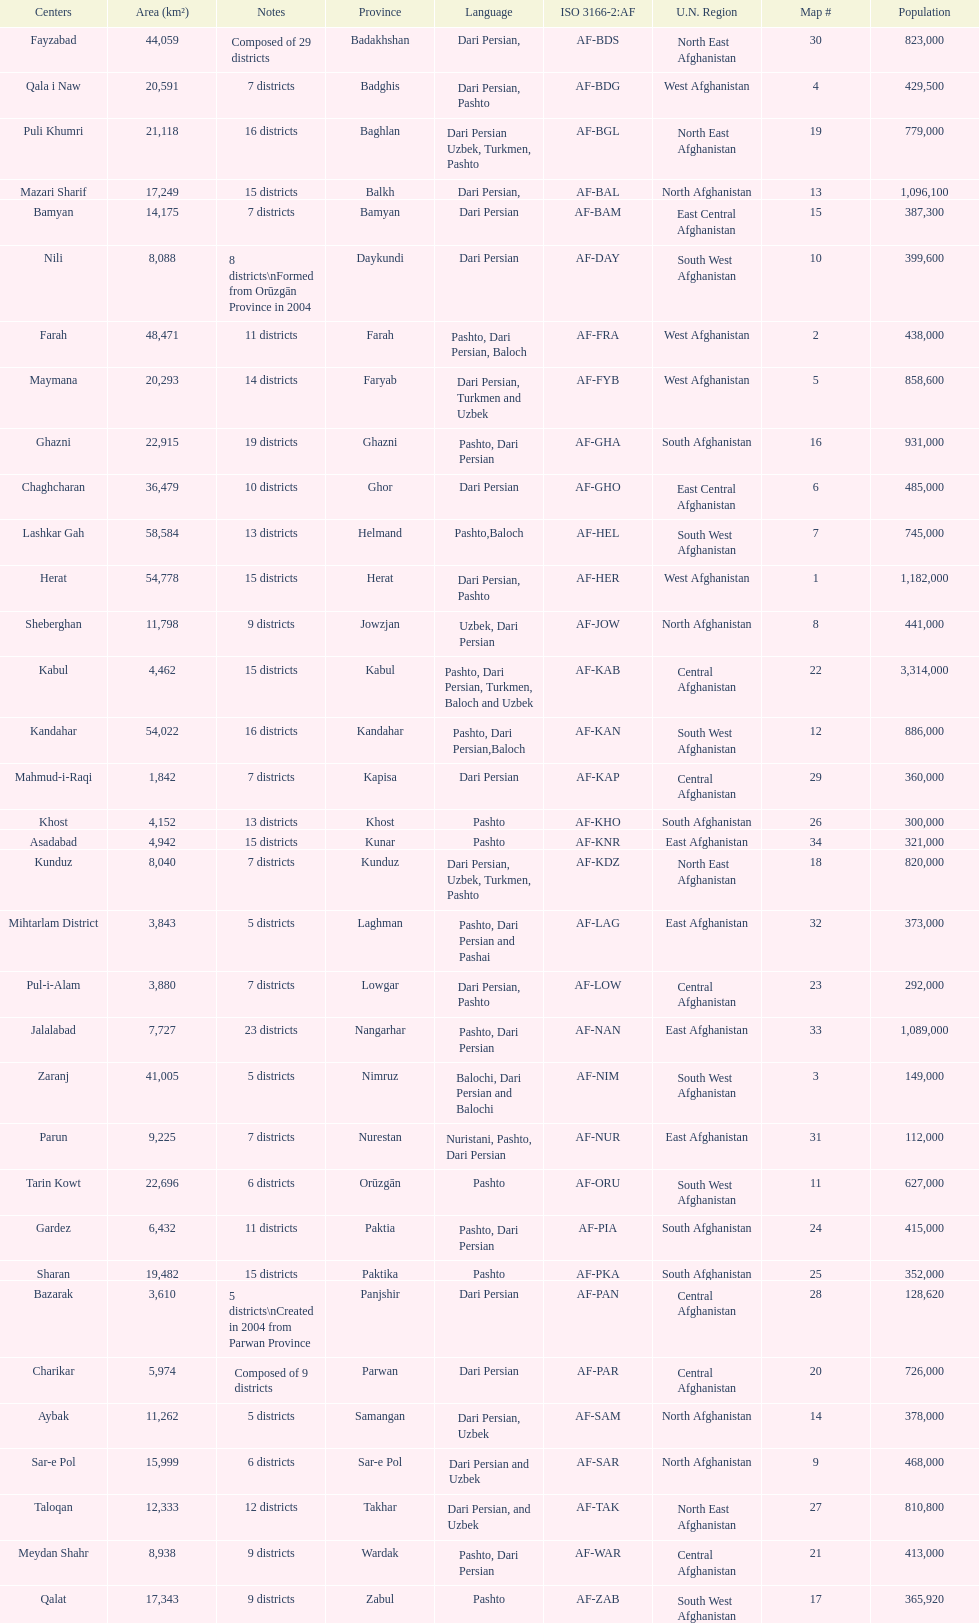How many provinces have the same number of districts as kabul? 4. Parse the full table. {'header': ['Centers', 'Area (km²)', 'Notes', 'Province', 'Language', 'ISO 3166-2:AF', 'U.N. Region', 'Map #', 'Population'], 'rows': [['Fayzabad', '44,059', 'Composed of 29 districts', 'Badakhshan', 'Dari Persian,', 'AF-BDS', 'North East Afghanistan', '30', '823,000'], ['Qala i Naw', '20,591', '7 districts', 'Badghis', 'Dari Persian, Pashto', 'AF-BDG', 'West Afghanistan', '4', '429,500'], ['Puli Khumri', '21,118', '16 districts', 'Baghlan', 'Dari Persian Uzbek, Turkmen, Pashto', 'AF-BGL', 'North East Afghanistan', '19', '779,000'], ['Mazari Sharif', '17,249', '15 districts', 'Balkh', 'Dari Persian,', 'AF-BAL', 'North Afghanistan', '13', '1,096,100'], ['Bamyan', '14,175', '7 districts', 'Bamyan', 'Dari Persian', 'AF-BAM', 'East Central Afghanistan', '15', '387,300'], ['Nili', '8,088', '8 districts\\nFormed from Orūzgān Province in 2004', 'Daykundi', 'Dari Persian', 'AF-DAY', 'South West Afghanistan', '10', '399,600'], ['Farah', '48,471', '11 districts', 'Farah', 'Pashto, Dari Persian, Baloch', 'AF-FRA', 'West Afghanistan', '2', '438,000'], ['Maymana', '20,293', '14 districts', 'Faryab', 'Dari Persian, Turkmen and Uzbek', 'AF-FYB', 'West Afghanistan', '5', '858,600'], ['Ghazni', '22,915', '19 districts', 'Ghazni', 'Pashto, Dari Persian', 'AF-GHA', 'South Afghanistan', '16', '931,000'], ['Chaghcharan', '36,479', '10 districts', 'Ghor', 'Dari Persian', 'AF-GHO', 'East Central Afghanistan', '6', '485,000'], ['Lashkar Gah', '58,584', '13 districts', 'Helmand', 'Pashto,Baloch', 'AF-HEL', 'South West Afghanistan', '7', '745,000'], ['Herat', '54,778', '15 districts', 'Herat', 'Dari Persian, Pashto', 'AF-HER', 'West Afghanistan', '1', '1,182,000'], ['Sheberghan', '11,798', '9 districts', 'Jowzjan', 'Uzbek, Dari Persian', 'AF-JOW', 'North Afghanistan', '8', '441,000'], ['Kabul', '4,462', '15 districts', 'Kabul', 'Pashto, Dari Persian, Turkmen, Baloch and Uzbek', 'AF-KAB', 'Central Afghanistan', '22', '3,314,000'], ['Kandahar', '54,022', '16 districts', 'Kandahar', 'Pashto, Dari Persian,Baloch', 'AF-KAN', 'South West Afghanistan', '12', '886,000'], ['Mahmud-i-Raqi', '1,842', '7 districts', 'Kapisa', 'Dari Persian', 'AF-KAP', 'Central Afghanistan', '29', '360,000'], ['Khost', '4,152', '13 districts', 'Khost', 'Pashto', 'AF-KHO', 'South Afghanistan', '26', '300,000'], ['Asadabad', '4,942', '15 districts', 'Kunar', 'Pashto', 'AF-KNR', 'East Afghanistan', '34', '321,000'], ['Kunduz', '8,040', '7 districts', 'Kunduz', 'Dari Persian, Uzbek, Turkmen, Pashto', 'AF-KDZ', 'North East Afghanistan', '18', '820,000'], ['Mihtarlam District', '3,843', '5 districts', 'Laghman', 'Pashto, Dari Persian and Pashai', 'AF-LAG', 'East Afghanistan', '32', '373,000'], ['Pul-i-Alam', '3,880', '7 districts', 'Lowgar', 'Dari Persian, Pashto', 'AF-LOW', 'Central Afghanistan', '23', '292,000'], ['Jalalabad', '7,727', '23 districts', 'Nangarhar', 'Pashto, Dari Persian', 'AF-NAN', 'East Afghanistan', '33', '1,089,000'], ['Zaranj', '41,005', '5 districts', 'Nimruz', 'Balochi, Dari Persian and Balochi', 'AF-NIM', 'South West Afghanistan', '3', '149,000'], ['Parun', '9,225', '7 districts', 'Nurestan', 'Nuristani, Pashto, Dari Persian', 'AF-NUR', 'East Afghanistan', '31', '112,000'], ['Tarin Kowt', '22,696', '6 districts', 'Orūzgān', 'Pashto', 'AF-ORU', 'South West Afghanistan', '11', '627,000'], ['Gardez', '6,432', '11 districts', 'Paktia', 'Pashto, Dari Persian', 'AF-PIA', 'South Afghanistan', '24', '415,000'], ['Sharan', '19,482', '15 districts', 'Paktika', 'Pashto', 'AF-PKA', 'South Afghanistan', '25', '352,000'], ['Bazarak', '3,610', '5 districts\\nCreated in 2004 from Parwan Province', 'Panjshir', 'Dari Persian', 'AF-PAN', 'Central Afghanistan', '28', '128,620'], ['Charikar', '5,974', 'Composed of 9 districts', 'Parwan', 'Dari Persian', 'AF-PAR', 'Central Afghanistan', '20', '726,000'], ['Aybak', '11,262', '5 districts', 'Samangan', 'Dari Persian, Uzbek', 'AF-SAM', 'North Afghanistan', '14', '378,000'], ['Sar-e Pol', '15,999', '6 districts', 'Sar-e Pol', 'Dari Persian and Uzbek', 'AF-SAR', 'North Afghanistan', '9', '468,000'], ['Taloqan', '12,333', '12 districts', 'Takhar', 'Dari Persian, and Uzbek', 'AF-TAK', 'North East Afghanistan', '27', '810,800'], ['Meydan Shahr', '8,938', '9 districts', 'Wardak', 'Pashto, Dari Persian', 'AF-WAR', 'Central Afghanistan', '21', '413,000'], ['Qalat', '17,343', '9 districts', 'Zabul', 'Pashto', 'AF-ZAB', 'South West Afghanistan', '17', '365,920']]} 